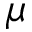<formula> <loc_0><loc_0><loc_500><loc_500>\mu</formula> 